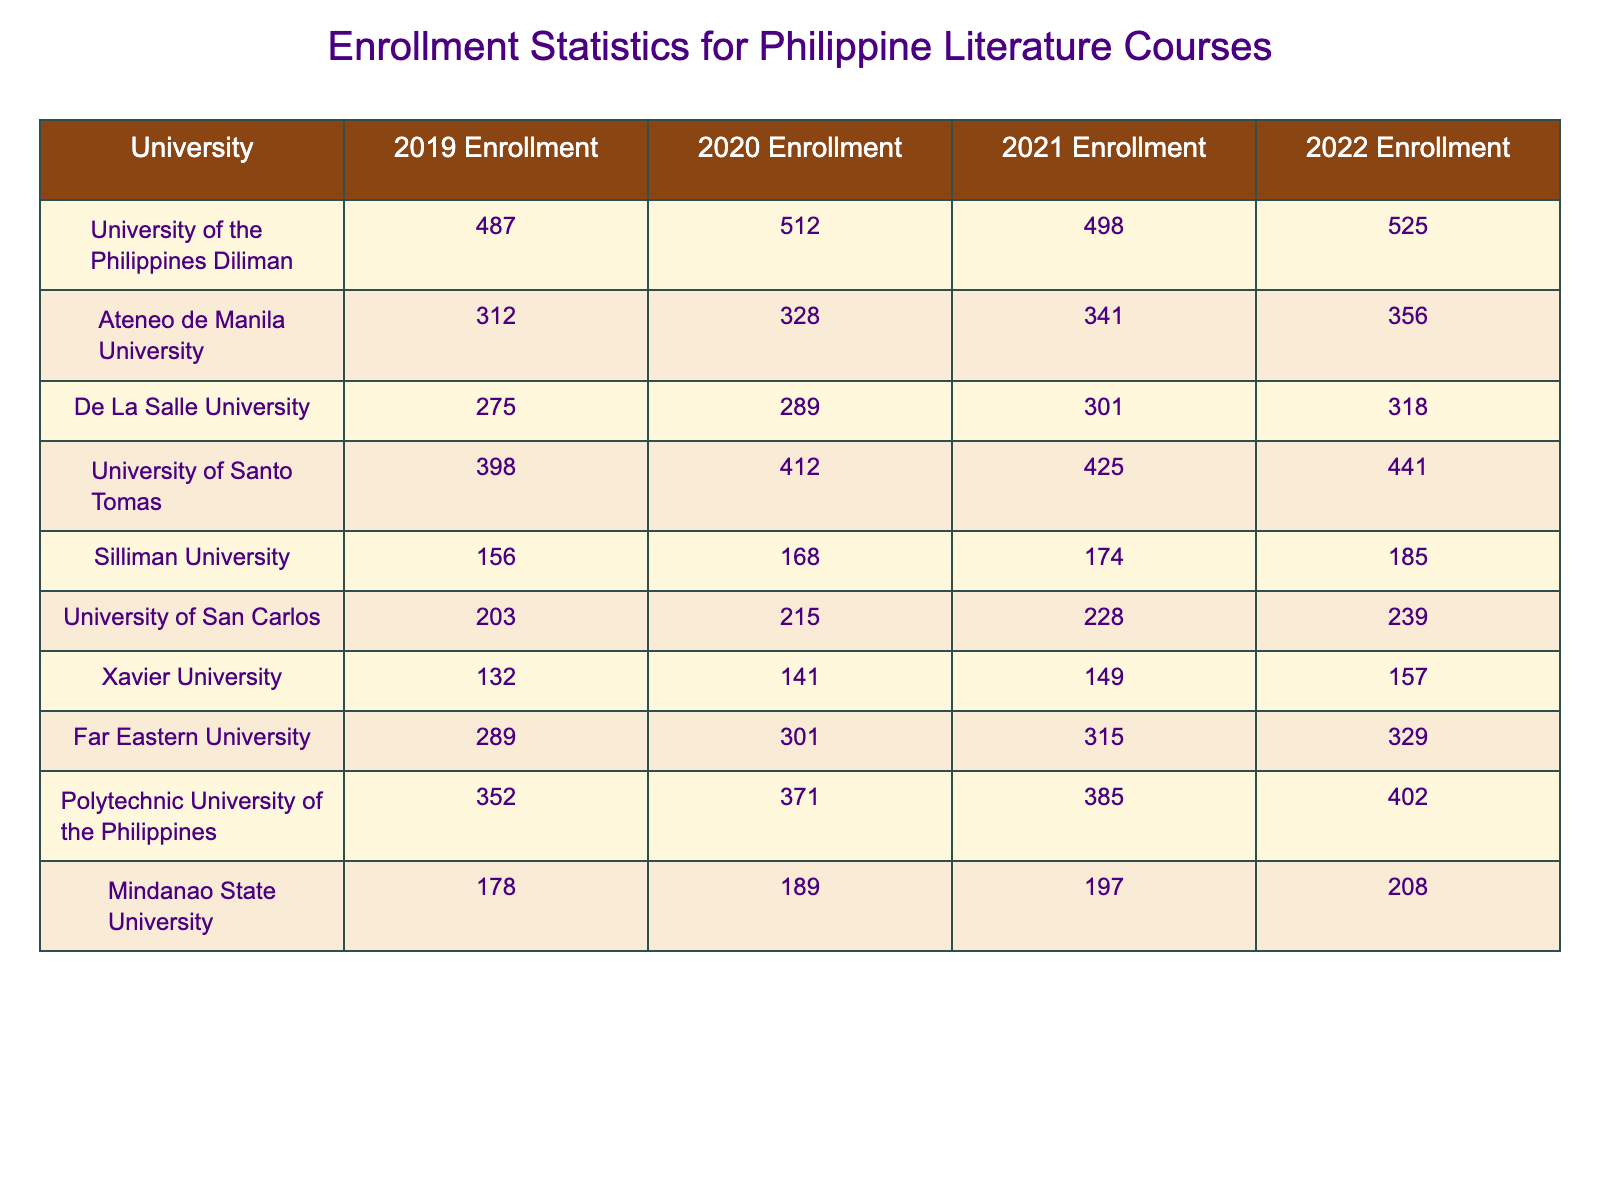What was the enrollment for Philippine Literature courses at the University of the Philippines Diliman in 2021? The table shows the enrollment for 2021 under the University of the Philippines Diliman column, which is 498.
Answer: 498 Which university had the highest enrollment in 2022? By reviewing the 2022 Enrollment column, the University of Santo Tomas has the highest enrollment with 441 students.
Answer: University of Santo Tomas What is the total enrollment for De La Salle University from 2019 to 2022? Adding the enrollment figures from 2019 (275), 2020 (289), 2021 (301), and 2022 (318) gives a total of 275 + 289 + 301 + 318 = 1183.
Answer: 1183 Did Far Eastern University have an increase in enrollment every year from 2019 to 2022? The enrollment figures for Far Eastern University are 289, 301, 315, and 329 for the respective years, showing a consistent increase.
Answer: Yes Calculate the average enrollment for Silliman University over the four years. The total enrollment for Silliman University is 156 + 168 + 174 + 185 = 683. Dividing by 4 years gives 683 / 4 = 170.75.
Answer: 170.75 What was the change in enrollment for the University of San Carlos from 2019 to 2022? The enrollment in 2019 was 203 and in 2022 it was 239. The change is calculated as 239 - 203 = 36.
Answer: 36 Which two universities had the lowest enrollment in 2020, and what were their numbers? In 2020, Silliman University had 168 and Xavier University had 141. These are the lowest enrollments in that year.
Answer: Silliman University (168), Xavier University (141) How much did enrollment at Ateneo de Manila University increase from 2019 to 2022? The enrollment increased from 312 in 2019 to 356 in 2022. The increase is 356 - 312 = 44.
Answer: 44 Is it true that all universities listed had more than 200 students enrolled in 2022? Checking the 2022 Enrollment column, only Xavier University had 157, which is less than 200, making the statement false.
Answer: No Which university had the second highest average enrollment over the four years? To find this, we first calculate the average for each university. After calculations, Ateneo de Manila University has an average of (312 + 328 + 341 + 356) / 4 = 334.25, making it the second highest after UST (average of 418.5).
Answer: Ateneo de Manila University 